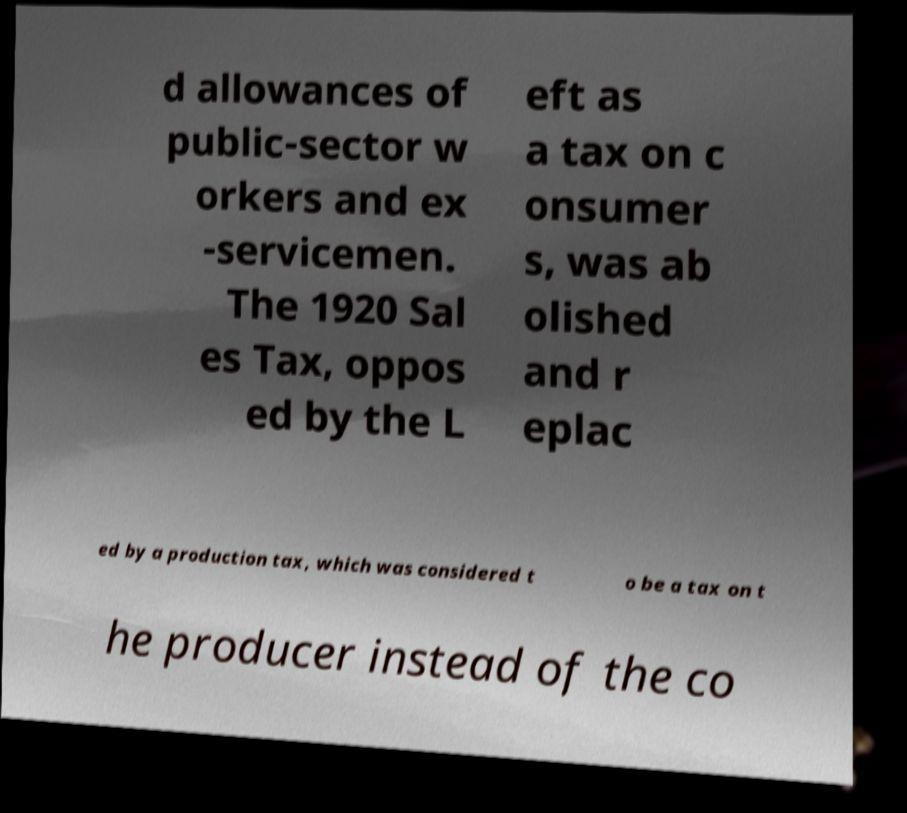Can you accurately transcribe the text from the provided image for me? d allowances of public-sector w orkers and ex -servicemen. The 1920 Sal es Tax, oppos ed by the L eft as a tax on c onsumer s, was ab olished and r eplac ed by a production tax, which was considered t o be a tax on t he producer instead of the co 